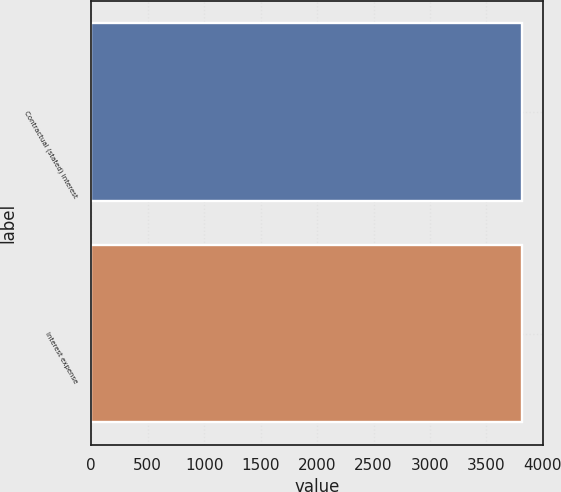Convert chart to OTSL. <chart><loc_0><loc_0><loc_500><loc_500><bar_chart><fcel>Contractual (stated) interest<fcel>Interest expense<nl><fcel>3812<fcel>3812.1<nl></chart> 